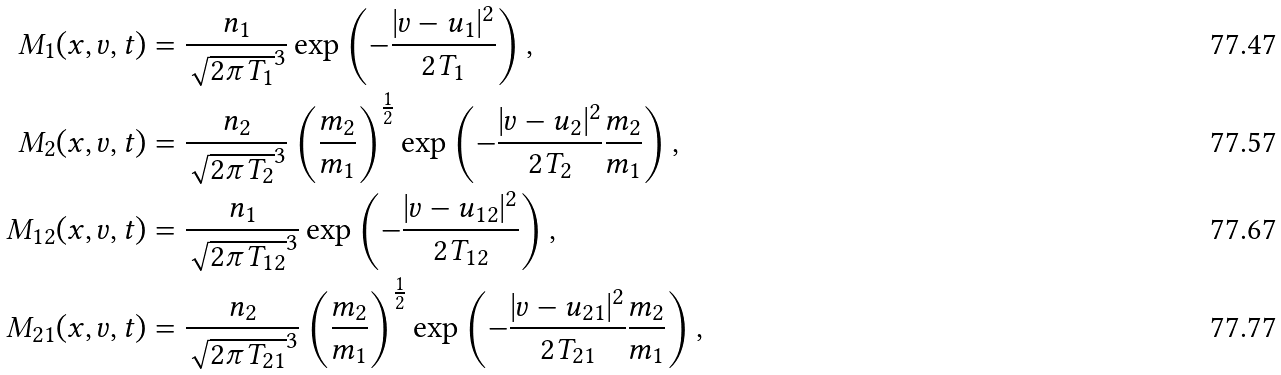<formula> <loc_0><loc_0><loc_500><loc_500>M _ { 1 } ( x , v , t ) & = \frac { n _ { 1 } } { \sqrt { 2 \pi T _ { 1 } } ^ { 3 } } \exp \left ( { - \frac { | v - u _ { 1 } | ^ { 2 } } { 2 T _ { 1 } } } \right ) , \\ M _ { 2 } ( x , v , t ) & = \frac { n _ { 2 } } { \sqrt { 2 \pi T _ { 2 } } ^ { 3 } } \left ( \frac { m _ { 2 } } { m _ { 1 } } \right ) ^ { \frac { 1 } { 2 } } \exp \left ( { - \frac { | v - u _ { 2 } | ^ { 2 } } { 2 T _ { 2 } } } \frac { m _ { 2 } } { m _ { 1 } } \right ) , \\ M _ { 1 2 } ( x , v , t ) & = \frac { n _ { 1 } } { \sqrt { 2 \pi T _ { 1 2 } } ^ { 3 } } \exp \left ( { - \frac { | v - u _ { 1 2 } | ^ { 2 } } { 2 T _ { 1 2 } } } \right ) , \\ M _ { 2 1 } ( x , v , t ) & = \frac { n _ { 2 } } { \sqrt { 2 \pi T _ { 2 1 } } ^ { 3 } } \left ( \frac { m _ { 2 } } { m _ { 1 } } \right ) ^ { \frac { 1 } { 2 } } \exp \left ( { - \frac { | v - u _ { 2 1 } | ^ { 2 } } { 2 T _ { 2 1 } } } \frac { m _ { 2 } } { m _ { 1 } } \right ) ,</formula> 